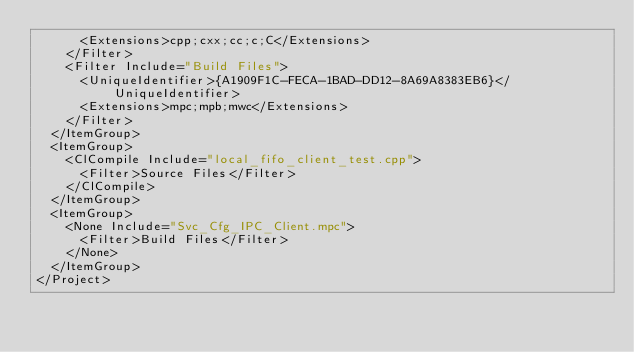<code> <loc_0><loc_0><loc_500><loc_500><_XML_>      <Extensions>cpp;cxx;cc;c;C</Extensions>
    </Filter>
    <Filter Include="Build Files">
      <UniqueIdentifier>{A1909F1C-FECA-1BAD-DD12-8A69A8383EB6}</UniqueIdentifier>
      <Extensions>mpc;mpb;mwc</Extensions>
    </Filter>
  </ItemGroup>
  <ItemGroup>
    <ClCompile Include="local_fifo_client_test.cpp">
      <Filter>Source Files</Filter>
    </ClCompile>
  </ItemGroup>
  <ItemGroup>
    <None Include="Svc_Cfg_IPC_Client.mpc">
      <Filter>Build Files</Filter>
    </None>
  </ItemGroup>
</Project>
</code> 